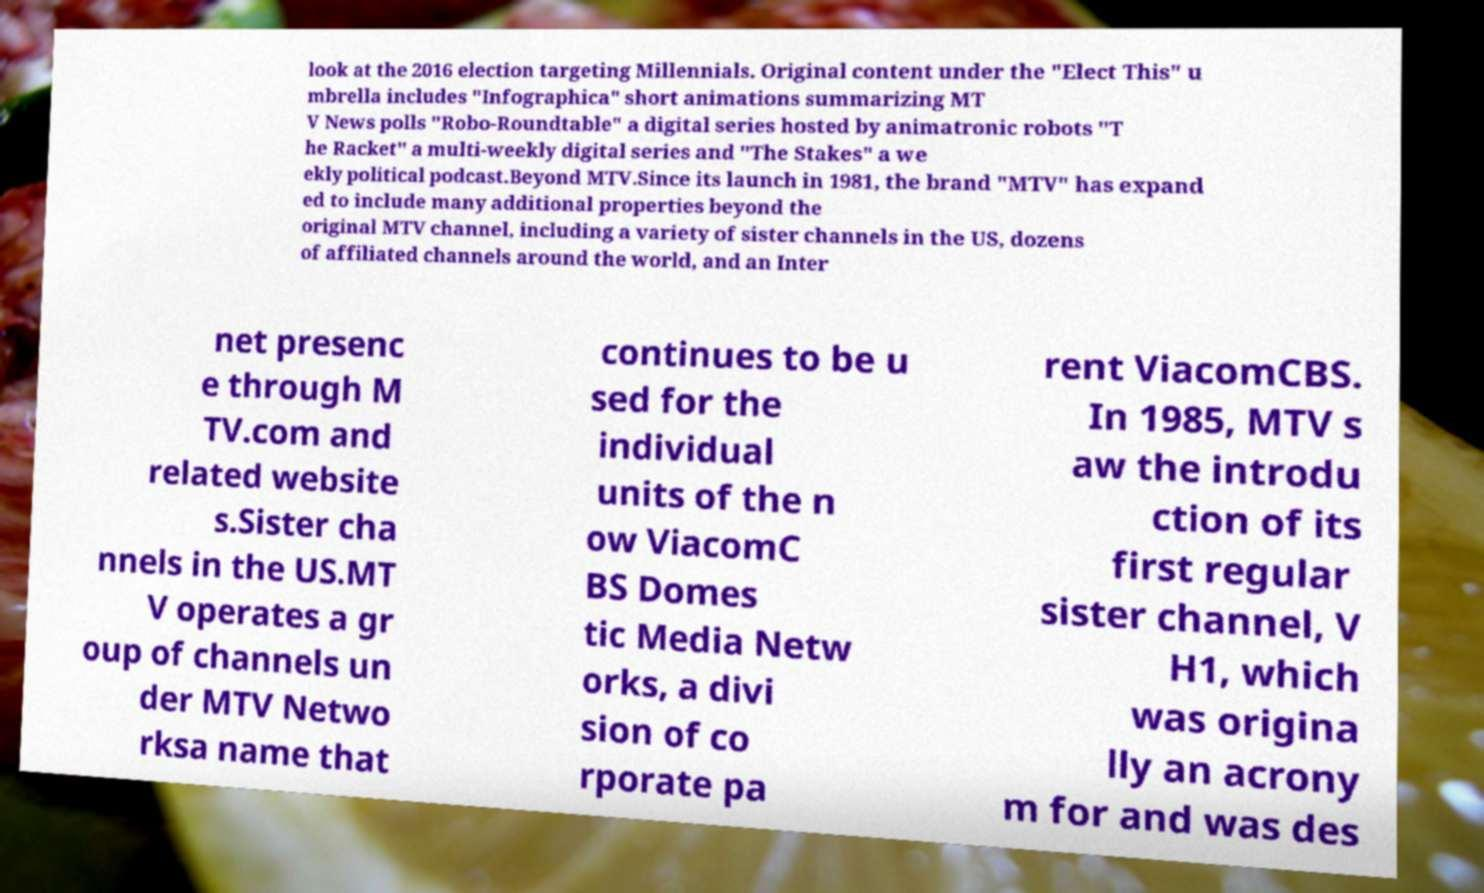Please read and relay the text visible in this image. What does it say? look at the 2016 election targeting Millennials. Original content under the "Elect This" u mbrella includes "Infographica" short animations summarizing MT V News polls "Robo-Roundtable" a digital series hosted by animatronic robots "T he Racket" a multi-weekly digital series and "The Stakes" a we ekly political podcast.Beyond MTV.Since its launch in 1981, the brand "MTV" has expand ed to include many additional properties beyond the original MTV channel, including a variety of sister channels in the US, dozens of affiliated channels around the world, and an Inter net presenc e through M TV.com and related website s.Sister cha nnels in the US.MT V operates a gr oup of channels un der MTV Netwo rksa name that continues to be u sed for the individual units of the n ow ViacomC BS Domes tic Media Netw orks, a divi sion of co rporate pa rent ViacomCBS. In 1985, MTV s aw the introdu ction of its first regular sister channel, V H1, which was origina lly an acrony m for and was des 